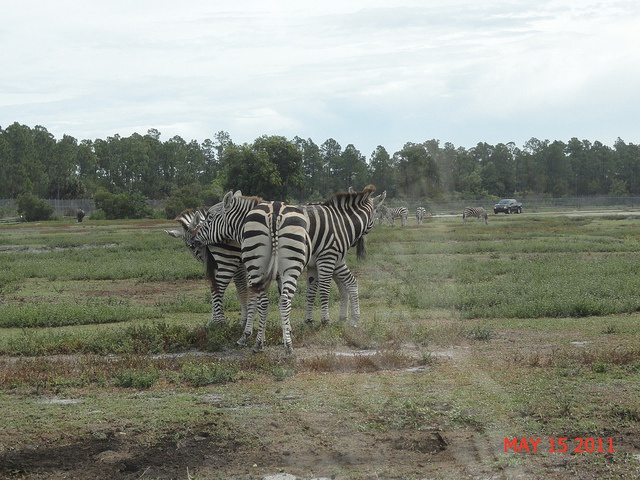Describe the objects in this image and their specific colors. I can see zebra in white, gray, black, and darkgray tones, zebra in white, gray, and black tones, zebra in white, gray, black, and darkgray tones, zebra in white, gray, and darkgray tones, and truck in white, gray, black, and darkgray tones in this image. 